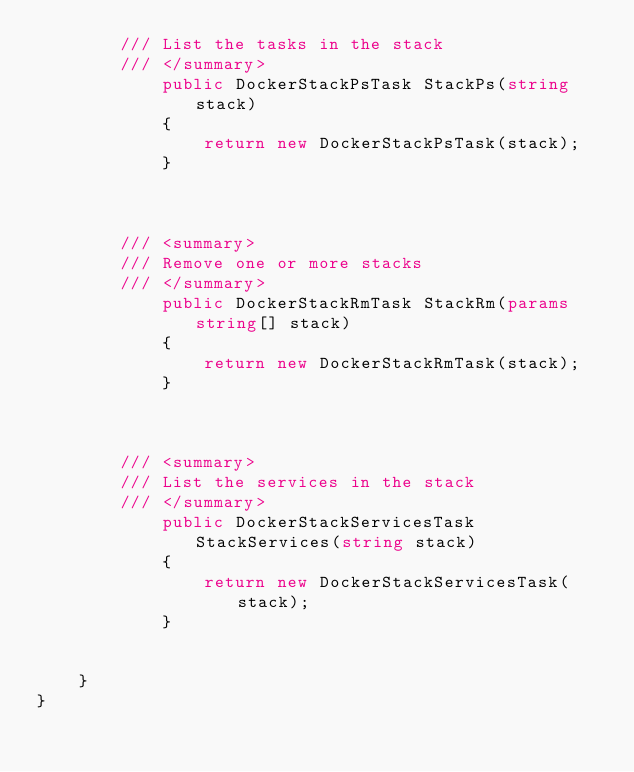<code> <loc_0><loc_0><loc_500><loc_500><_C#_>        /// List the tasks in the stack
        /// </summary>
            public DockerStackPsTask StackPs(string stack)
            {
                return new DockerStackPsTask(stack);
            }


            
        /// <summary>
        /// Remove one or more stacks
        /// </summary>
            public DockerStackRmTask StackRm(params string[] stack)
            {
                return new DockerStackRmTask(stack);
            }


            
        /// <summary>
        /// List the services in the stack
        /// </summary>
            public DockerStackServicesTask StackServices(string stack)
            {
                return new DockerStackServicesTask(stack);
            }

        
    }
}

</code> 